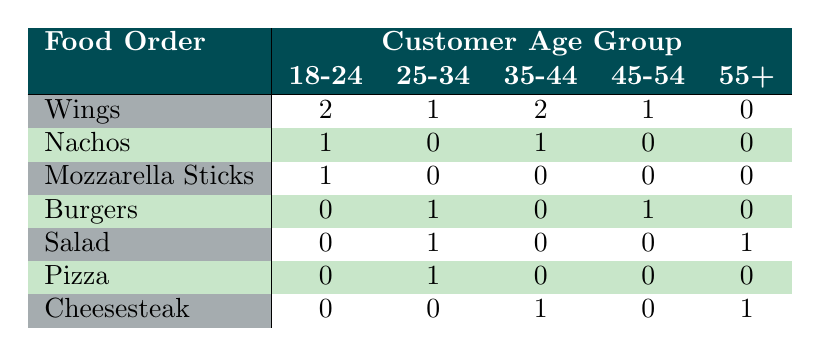What food order was the most popular among customers aged 35-44? The table shows that Wings and Cheesesteak were ordered by customers aged 35-44. Both have the same count of 2. Since the question asks for the most popular, we consider both.
Answer: Wings and Cheesesteak How many female customers ordered Wings? Looking at the table, we see that 1 female customer aged 18-24, 2 aged 35-44, and 1 aged 45-54 ordered Wings. Adding these counts together gives us 1 + 2 + 1 = 4.
Answer: 4 Did any customers aged 55 or older order Nachos? The table shows that there is no entry for Nachos under the age group of 55+, which means no customers aged 55 or older ordered Nachos.
Answer: No What is the total number of Burgers ordered by all age groups? Referring to the table, we find that only two customers ordered Burgers: 1 from the age group 25-34 and 1 from the age group 45-54. Adding these gives us 1 + 1 = 2 Burgers total.
Answer: 2 Which food order was the least popular overall? Reviewing the table, we note that both Salad and Nachos were ordered only once, which indicates they are tied for the least popular order.
Answer: Salad and Nachos How many males ordered food across all age groups? To find this, we will add all the male orders across age groups: 2 (18-24) + 2 (25-34) + 2 (35-44) + 1 (45-54) + 1 (55+) = 8 males ordered food in total.
Answer: 8 Did female customers order more different types of food than male customers? From the table, female customers ordered Wings, Nachos, Mozzarella Sticks, Burgers, Salad, Pizza, and Cheesesteak, totaling 7 different items. Male customers ordered Wings, Burgers, Salad, and Cheesesteak, totaling 4 different items. Therefore, females ordered more types of food.
Answer: Yes What is the total number of food orders from customers aged 18-24? In the table, customers aged 18-24 ordered Wings (2), Nachos (1), and Mozzarella Sticks (1). The total would be 2 + 1 + 1 = 4 orders from this age group.
Answer: 4 